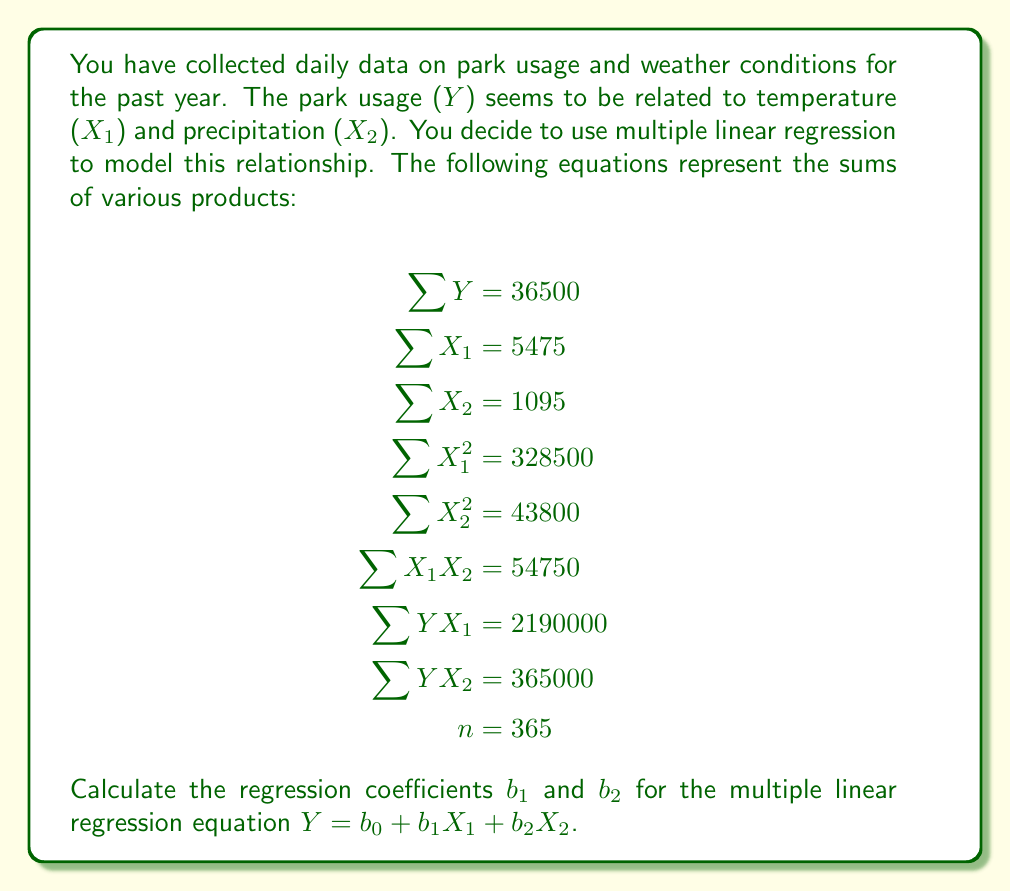Could you help me with this problem? To solve this problem, we'll use the normal equations for multiple linear regression:

1) $\sum Y = nb_0 + b_1\sum X_1 + b_2\sum X_2$
2) $\sum YX_1 = b_0\sum X_1 + b_1\sum X_1^2 + b_2\sum X_1X_2$
3) $\sum YX_2 = b_0\sum X_2 + b_1\sum X_1X_2 + b_2\sum X_2^2$

Let's substitute the given values:

1) $36500 = 365b_0 + 5475b_1 + 1095b_2$
2) $2190000 = 5475b_0 + 328500b_1 + 54750b_2$
3) $365000 = 1095b_0 + 54750b_1 + 43800b_2$

Now, we need to solve this system of equations. Let's use elimination method:

Multiply equation 1 by 15 and subtract from equation 2:
$547500 = 5475b_0 + 82125b_1 + 16425b_2$
$2190000 = 5475b_0 + 328500b_1 + 54750b_2$
$1642500 = 246375b_1 + 38325b_2$ ... (4)

Multiply equation 1 by 3 and subtract from equation 3:
$109500 = 1095b_0 + 16425b_1 + 3285b_2$
$365000 = 1095b_0 + 54750b_1 + 43800b_2$
$255500 = 38325b_1 + 40515b_2$ ... (5)

Now we have two equations with two unknowns. Let's solve for $b_1$ and $b_2$:

Multiply equation 5 by 6.42 and subtract from equation 4:
$1642500 = 246375b_1 + 38325b_2$
$1640310 = 246046.5b_1 + 260106.3b_2$
$2190 = 328.5b_1 - 221781.3b_2$

$b_1 = \frac{2190 + 221781.3b_2}{328.5}$ ... (6)

Substitute this into equation 5:
$255500 = 38325(\frac{2190 + 221781.3b_2}{328.5}) + 40515b_2$
$255500 = 4470 + 452700b_2 + 40515b_2$
$251030 = 493215b_2$
$b_2 = 0.509$

Now substitute this back into equation 6:
$b_1 = \frac{2190 + 221781.3(0.509)}{328.5} = 344.5$

Therefore, $b_1 \approx 344.5$ and $b_2 \approx 0.509$.
Answer: $b_1 \approx 344.5$, $b_2 \approx 0.509$ 